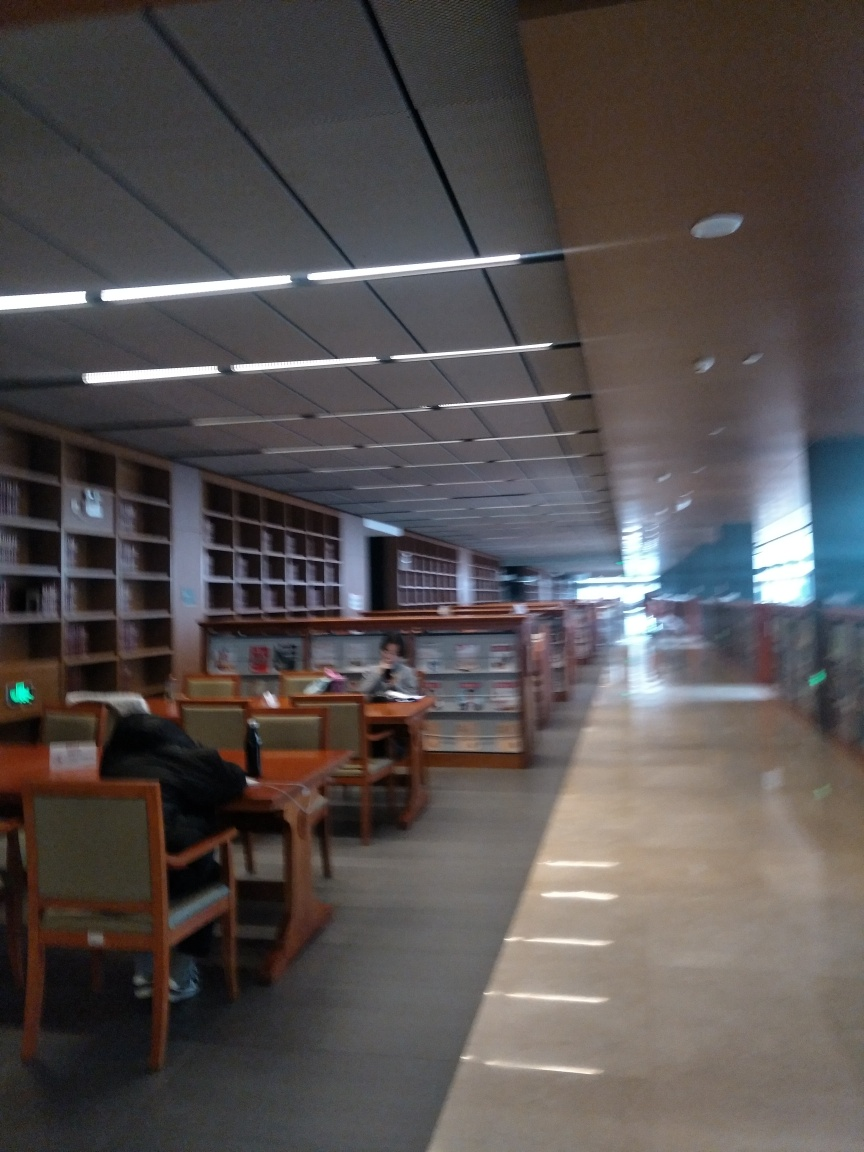Is the image well-lit? The image captures an indoor scene with moderate lighting, primarily from ceiling fixtures that cast an even light throughout the area. The brightness level is adequate for the space's intended use as a library, allowing for comfortable reading and studying without excessive glare or shadows. 